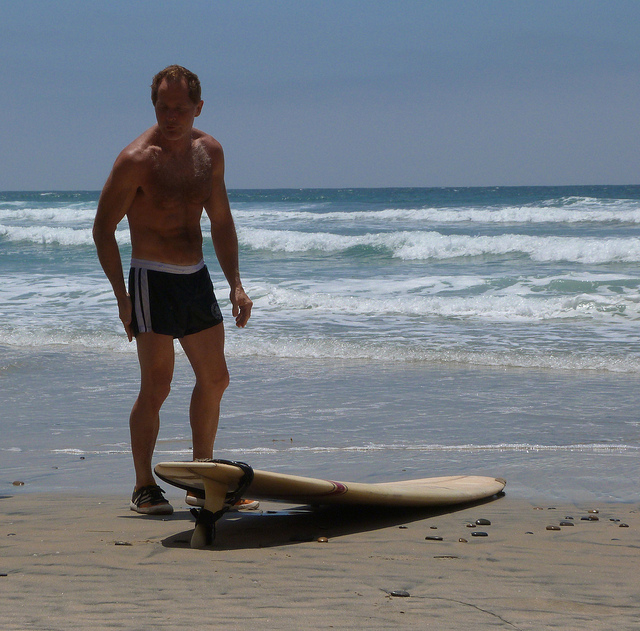Create a short story based on the image. As the morning sun filtered through the hazy skies, Jack stood on the beach, looking down at his trusted surfboard. The cool breeze ruffled his hair, while the rhythmic sound of the waves provided a calming soundtrack. He had been surfing these waters for years, but each day brought a new challenge. With the leash securely strapped to his ankle, Jack took a moment to appreciate the tranquility before heading into the choppy waves for another thrilling ride. 